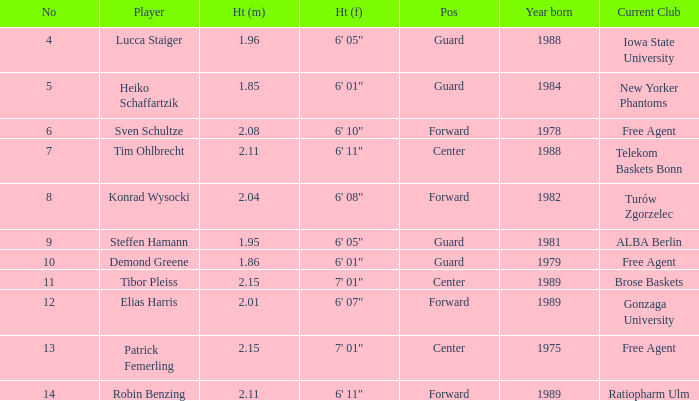Determine the height of the sportsman born in 198 1.95. 